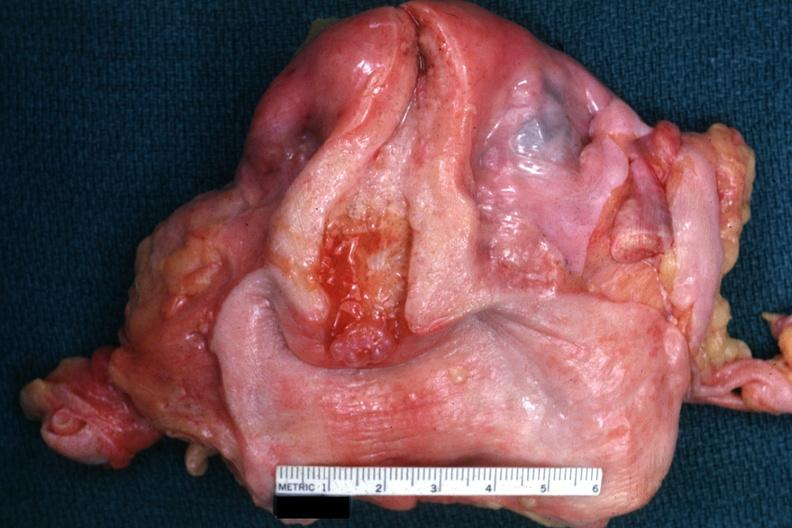what is present?
Answer the question using a single word or phrase. Endocervical polyp 